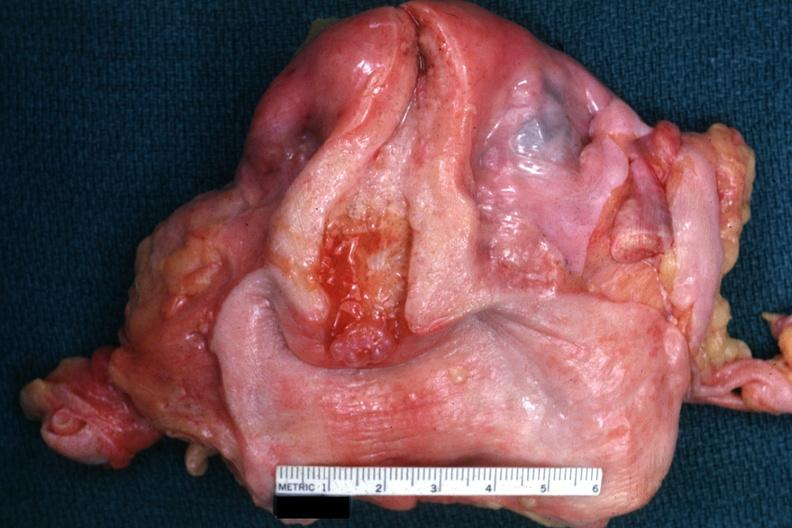what is present?
Answer the question using a single word or phrase. Endocervical polyp 